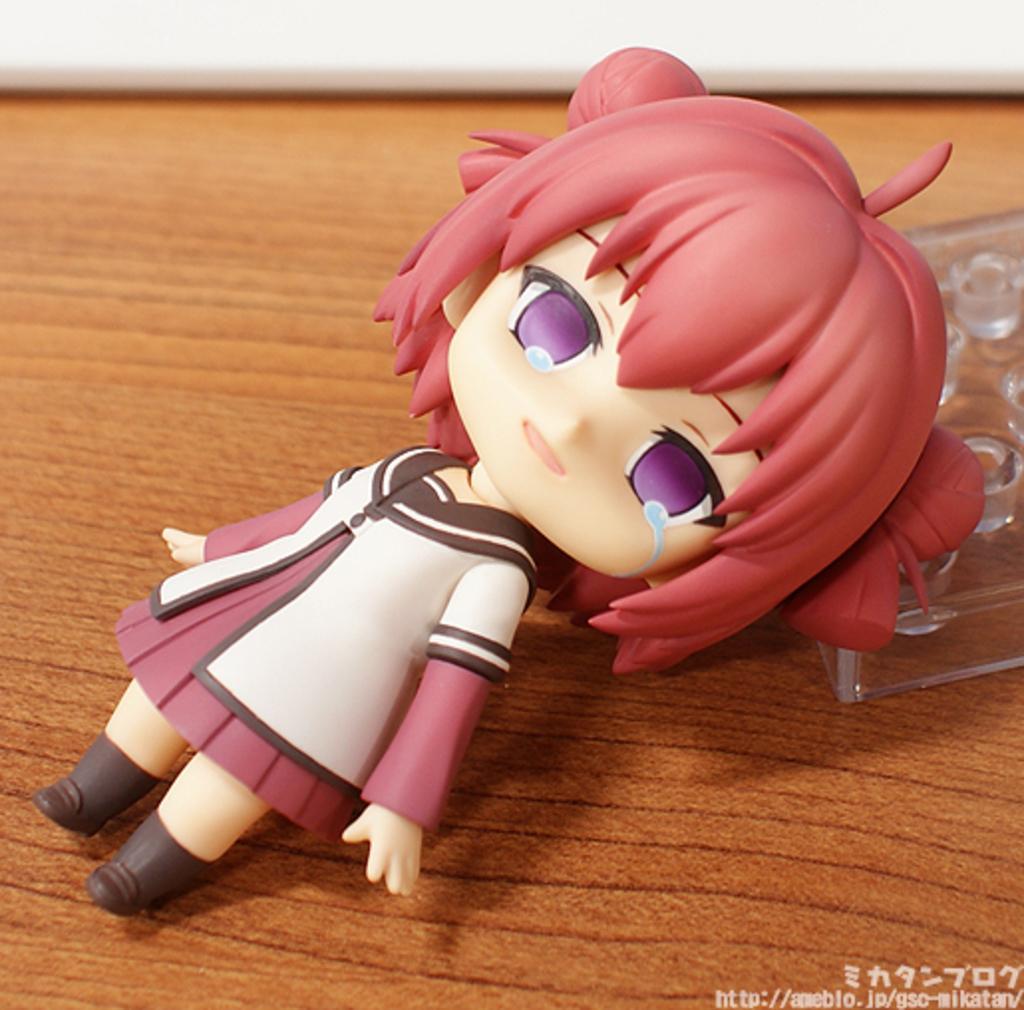Could you give a brief overview of what you see in this image? In this image I can see a doll and on the right side of the image I can see a plastic thing. On the bottom right side of the image I can see a watermark. 